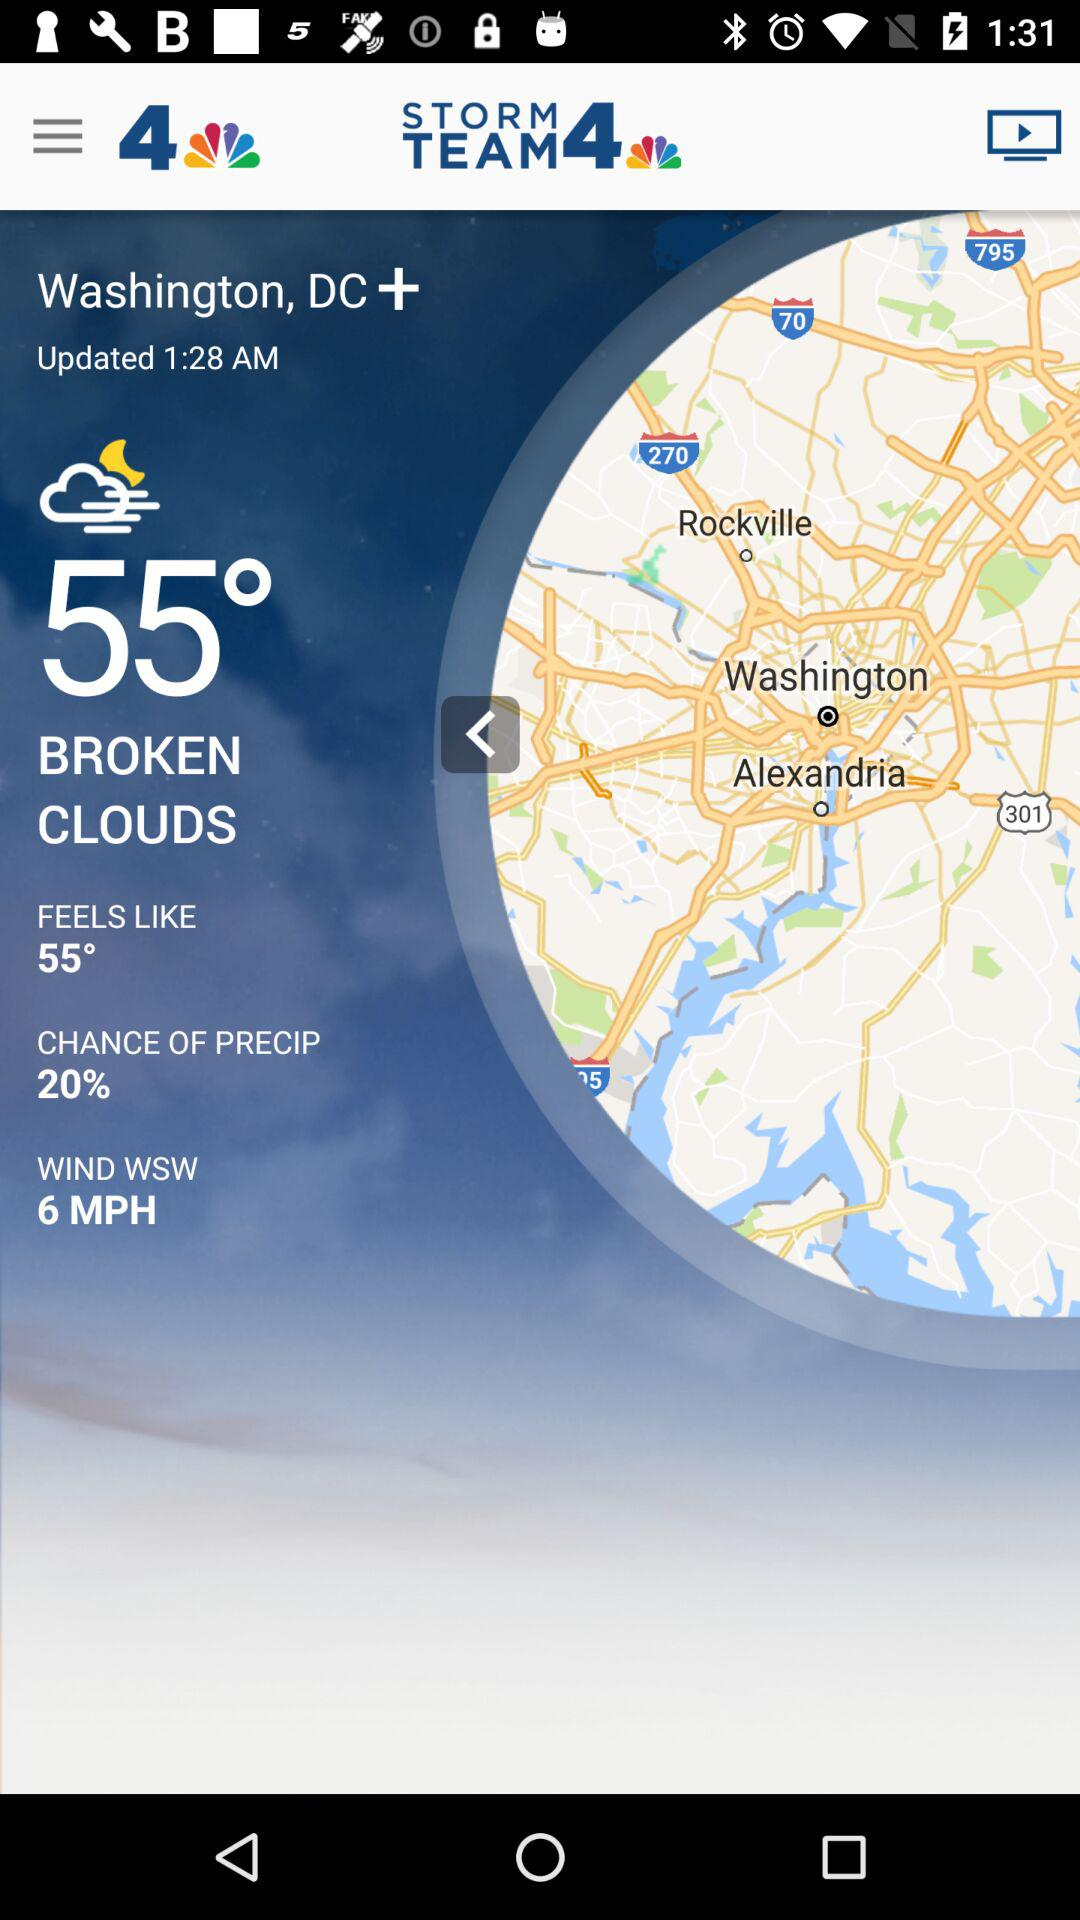How many more degrees is the temperature than the wind speed?
Answer the question using a single word or phrase. 49 